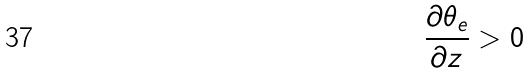<formula> <loc_0><loc_0><loc_500><loc_500>\frac { \partial \theta _ { e } } { \partial z } > 0</formula> 